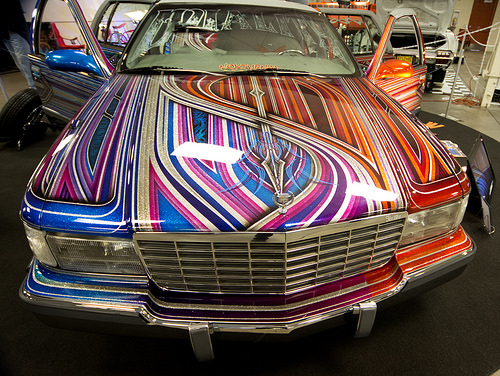<image>
Is there a headlight under the door? No. The headlight is not positioned under the door. The vertical relationship between these objects is different. Is the paint in front of the car? No. The paint is not in front of the car. The spatial positioning shows a different relationship between these objects. 